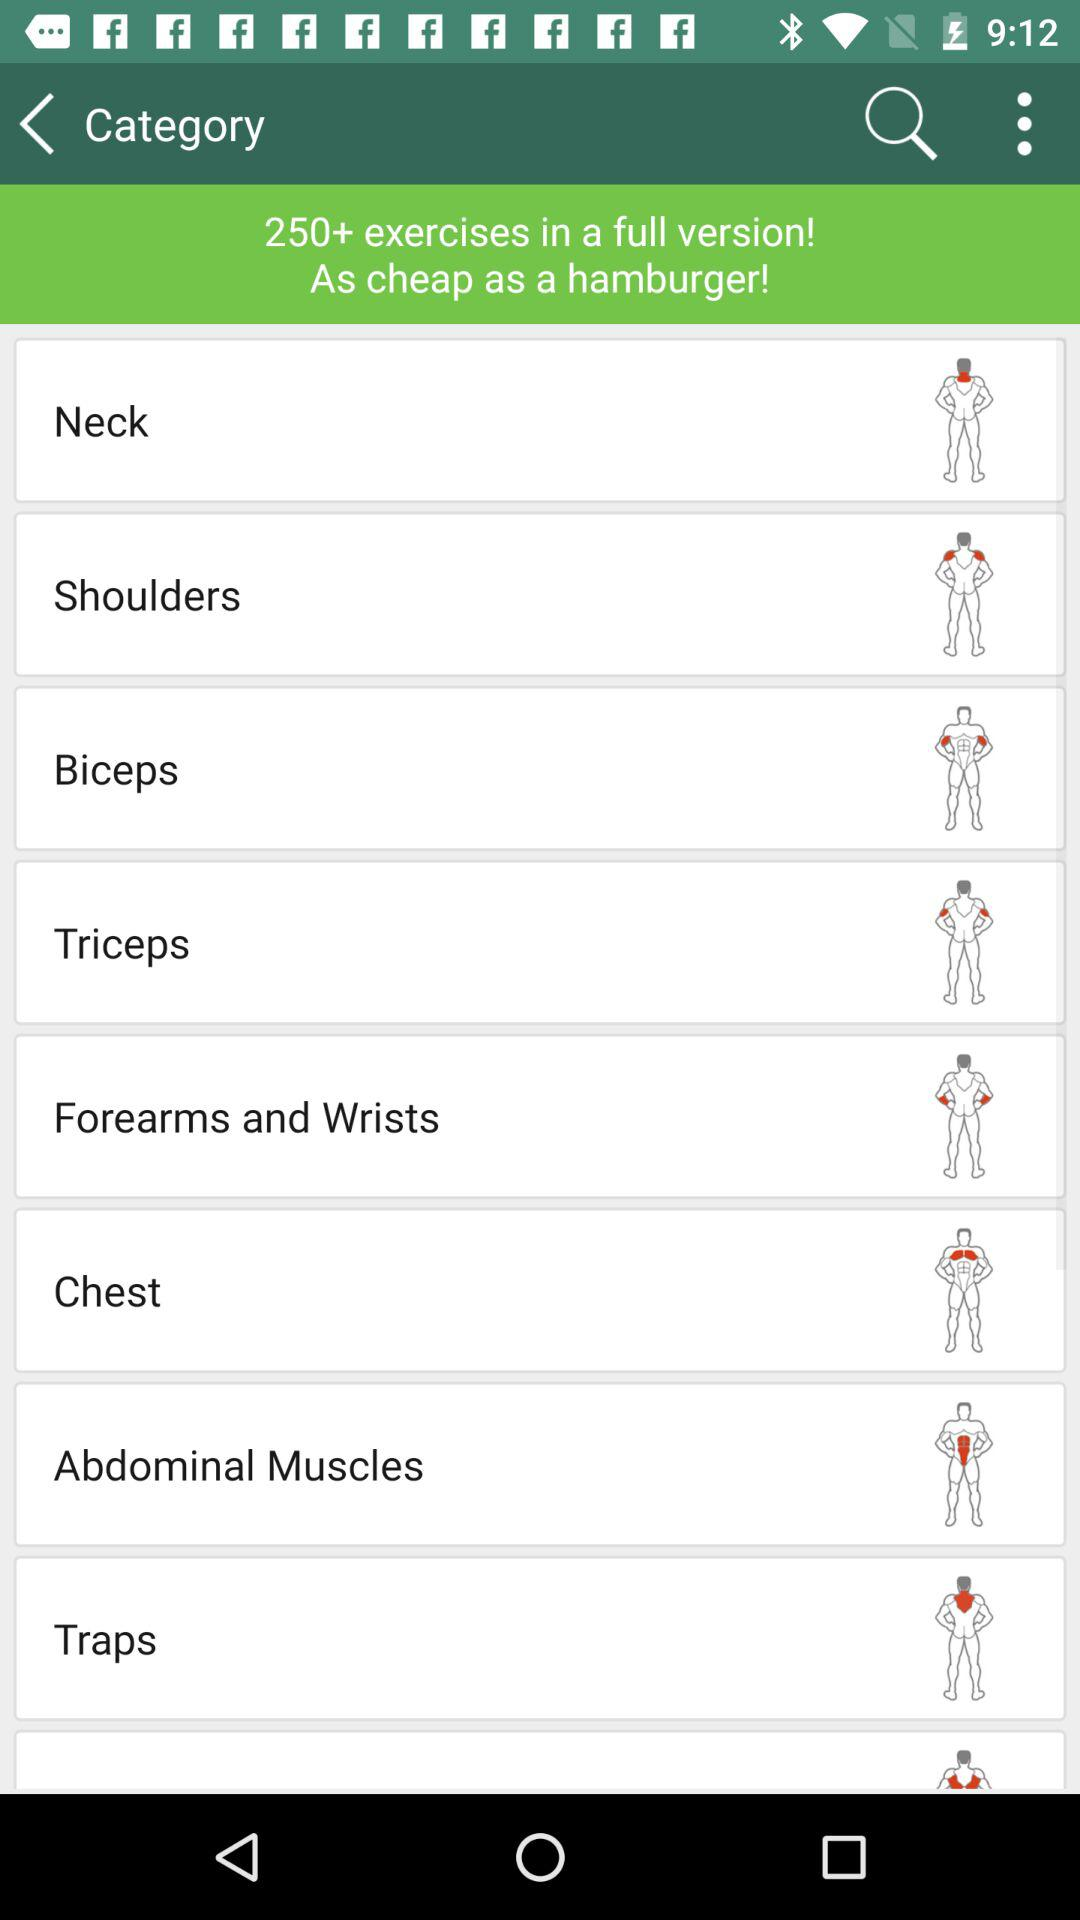How many exercises are there in a full version? There are more than 250 exercises in a full version. 